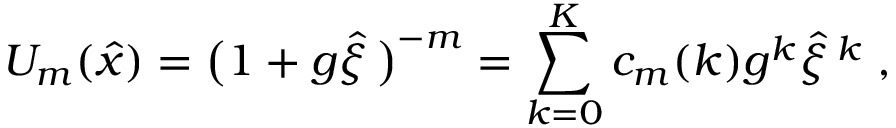<formula> <loc_0><loc_0><loc_500><loc_500>U _ { m } ( \hat { x } ) = \left ( 1 + g \hat { \xi } \, \right ) ^ { - m } = \sum _ { k = 0 } ^ { K } c _ { m } ( k ) g ^ { k } \hat { \xi } \, ^ { k } \, ,</formula> 